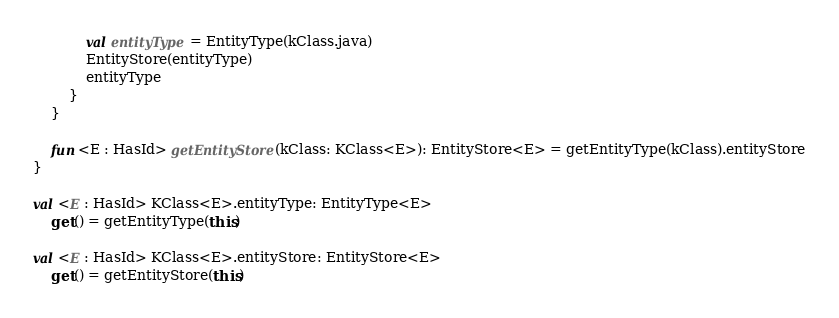<code> <loc_0><loc_0><loc_500><loc_500><_Kotlin_>            val entityType = EntityType(kClass.java)
            EntityStore(entityType)
            entityType
        }
    }

    fun <E : HasId> getEntityStore(kClass: KClass<E>): EntityStore<E> = getEntityType(kClass).entityStore
}

val <E : HasId> KClass<E>.entityType: EntityType<E>
    get() = getEntityType(this)

val <E : HasId> KClass<E>.entityStore: EntityStore<E>
    get() = getEntityStore(this)
</code> 